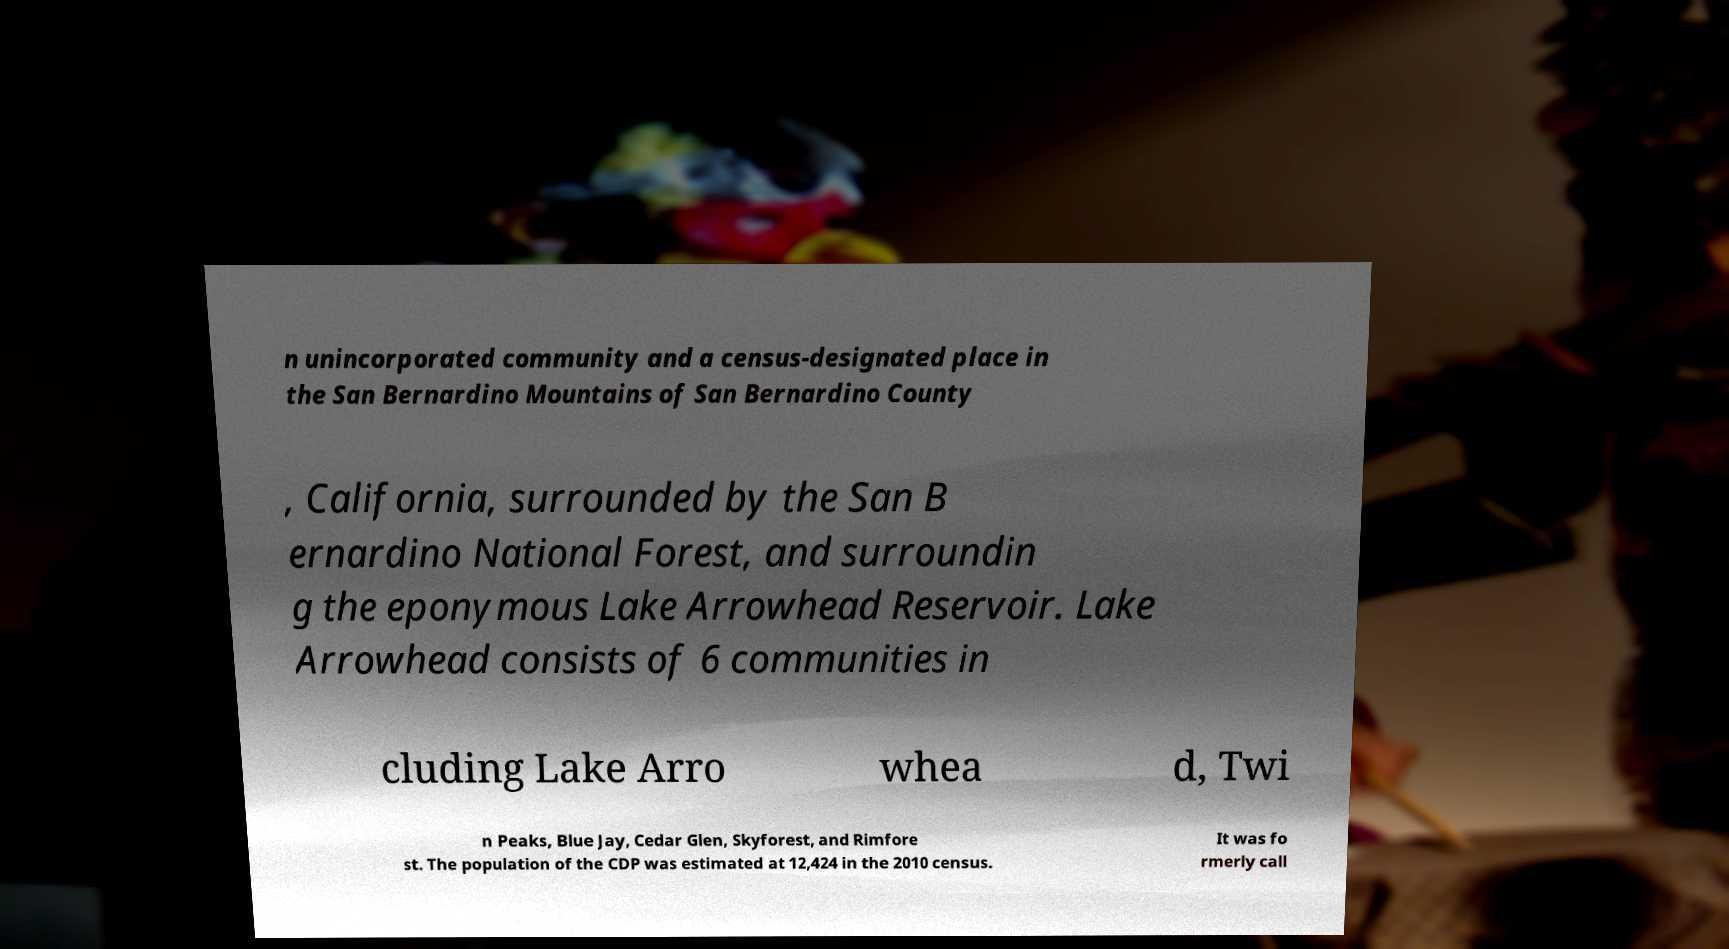Could you extract and type out the text from this image? n unincorporated community and a census-designated place in the San Bernardino Mountains of San Bernardino County , California, surrounded by the San B ernardino National Forest, and surroundin g the eponymous Lake Arrowhead Reservoir. Lake Arrowhead consists of 6 communities in cluding Lake Arro whea d, Twi n Peaks, Blue Jay, Cedar Glen, Skyforest, and Rimfore st. The population of the CDP was estimated at 12,424 in the 2010 census. It was fo rmerly call 